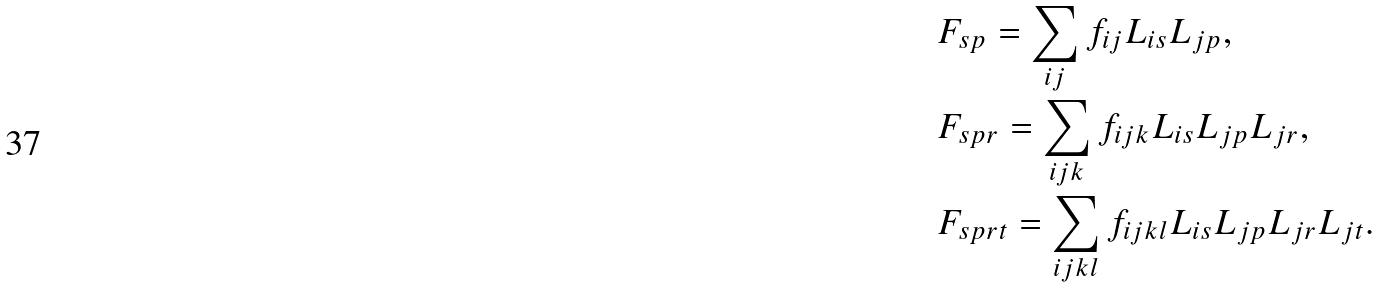Convert formula to latex. <formula><loc_0><loc_0><loc_500><loc_500>& F _ { s p } = \sum _ { i j } f _ { i j } L _ { i s } L _ { j p } , \\ & F _ { s p r } = \sum _ { i j k } f _ { i j k } L _ { i s } L _ { j p } L _ { j r } , \\ & F _ { s p r t } = \sum _ { i j k l } f _ { i j k l } L _ { i s } L _ { j p } L _ { j r } L _ { j t } .</formula> 